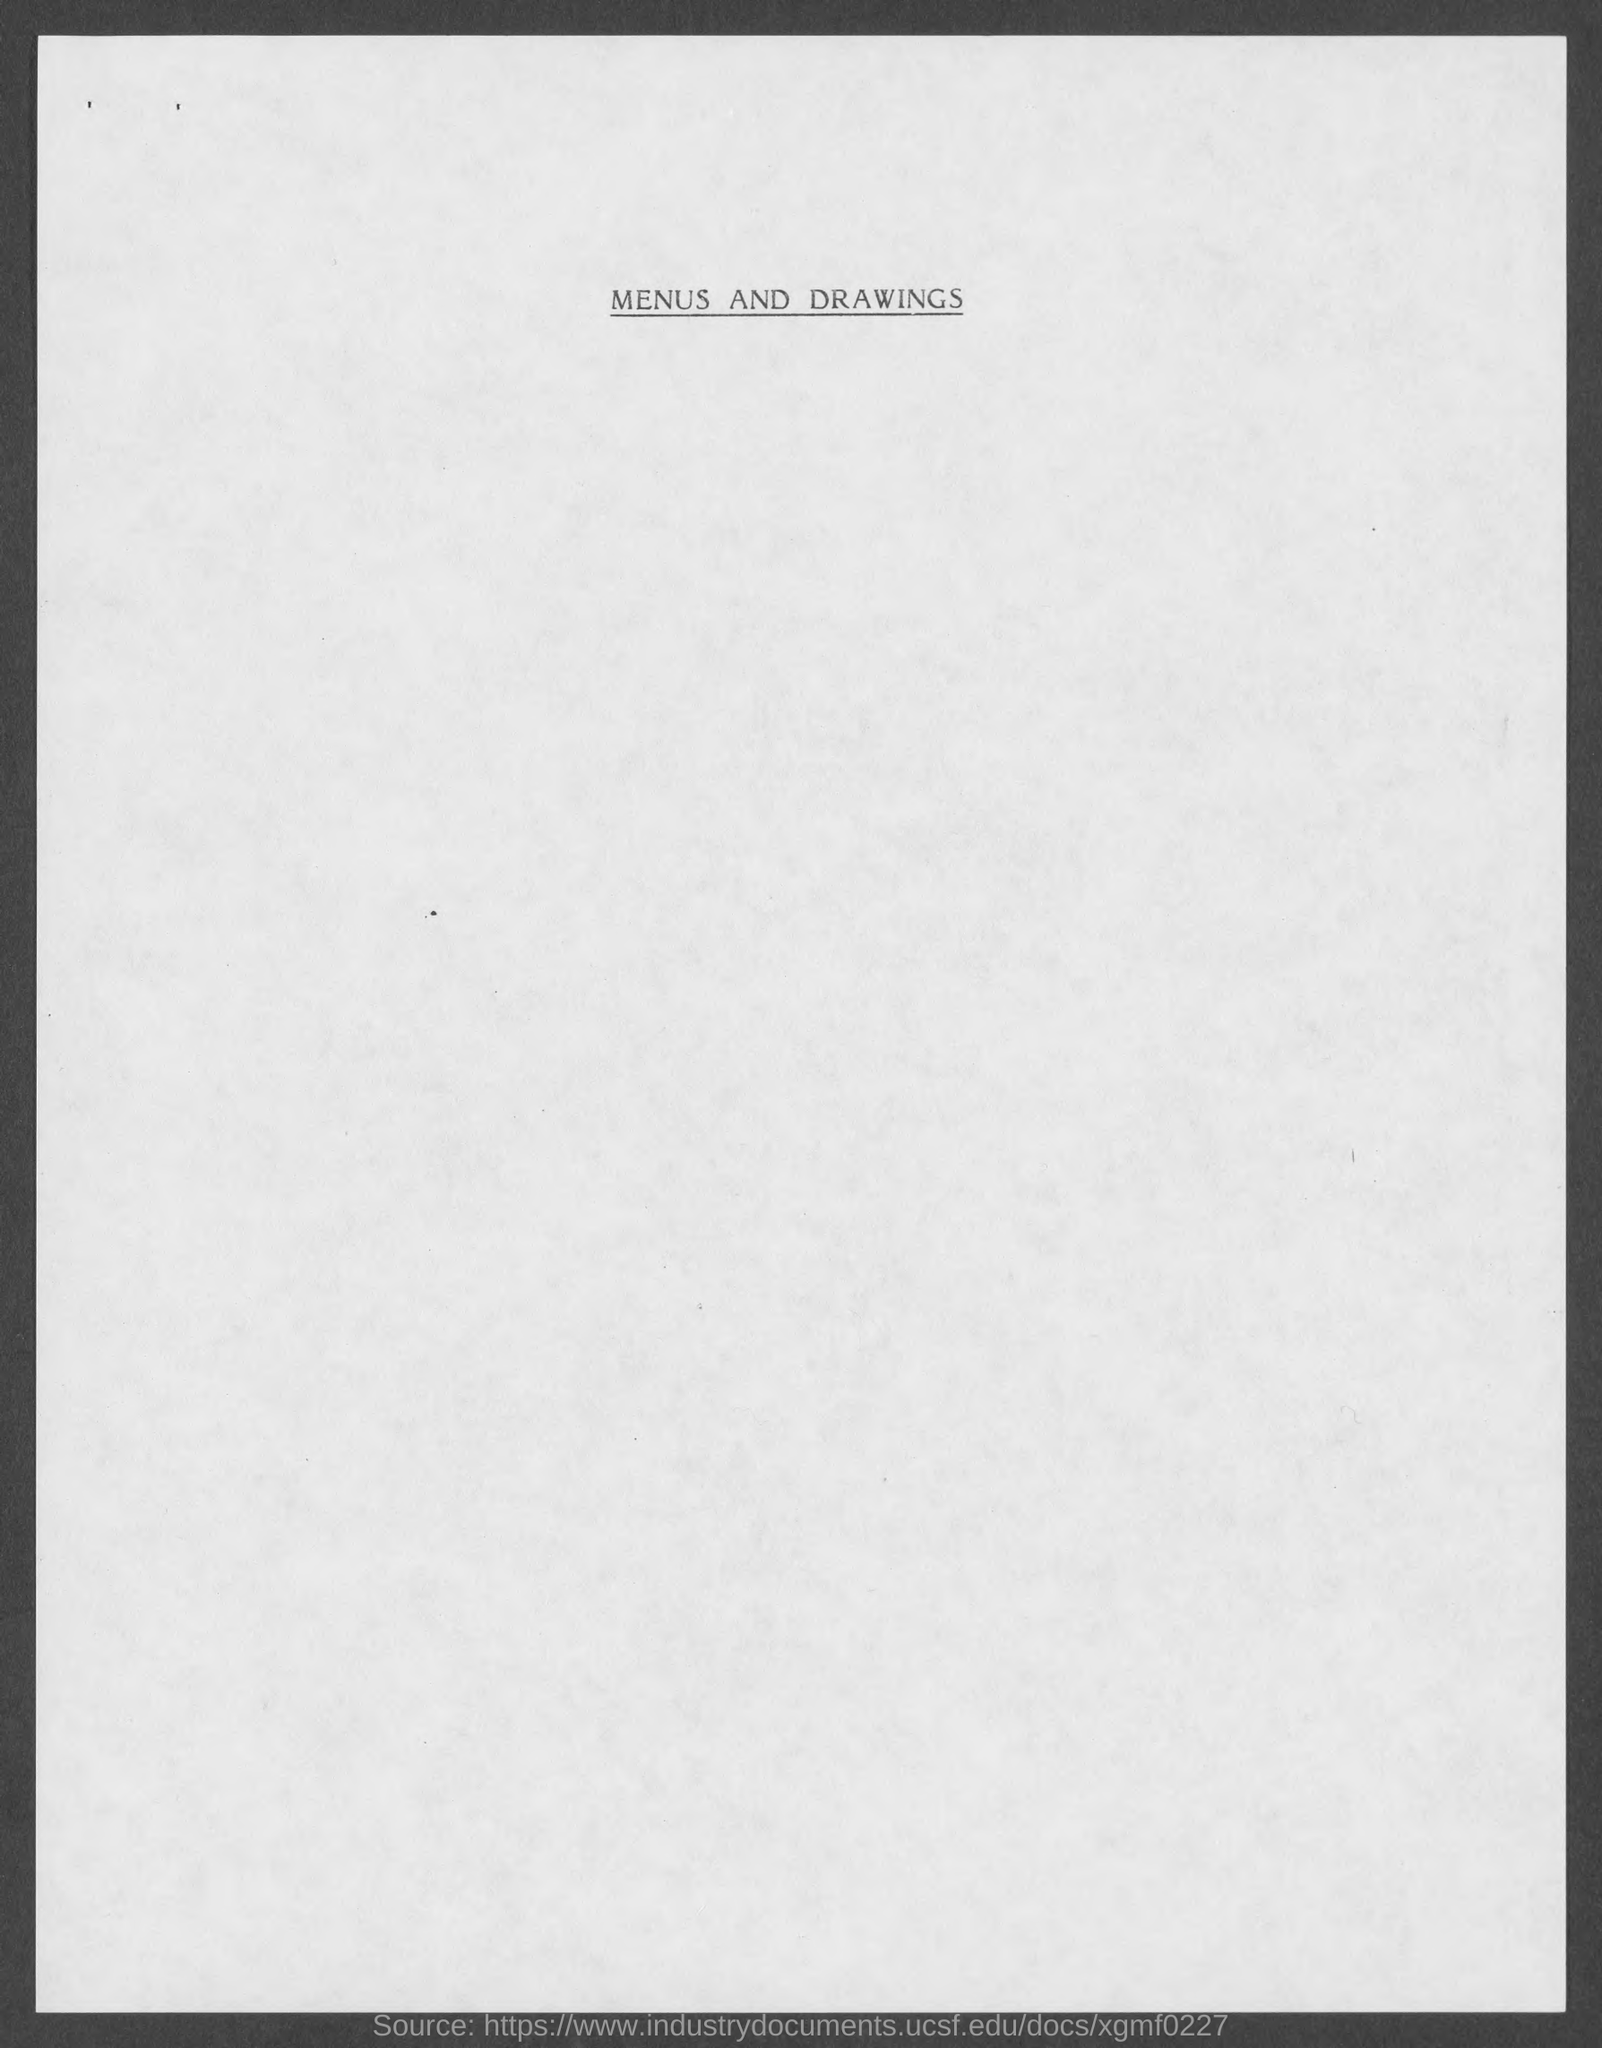Identify some key points in this picture. The heading of the document on top is "Menus and Drawings. 